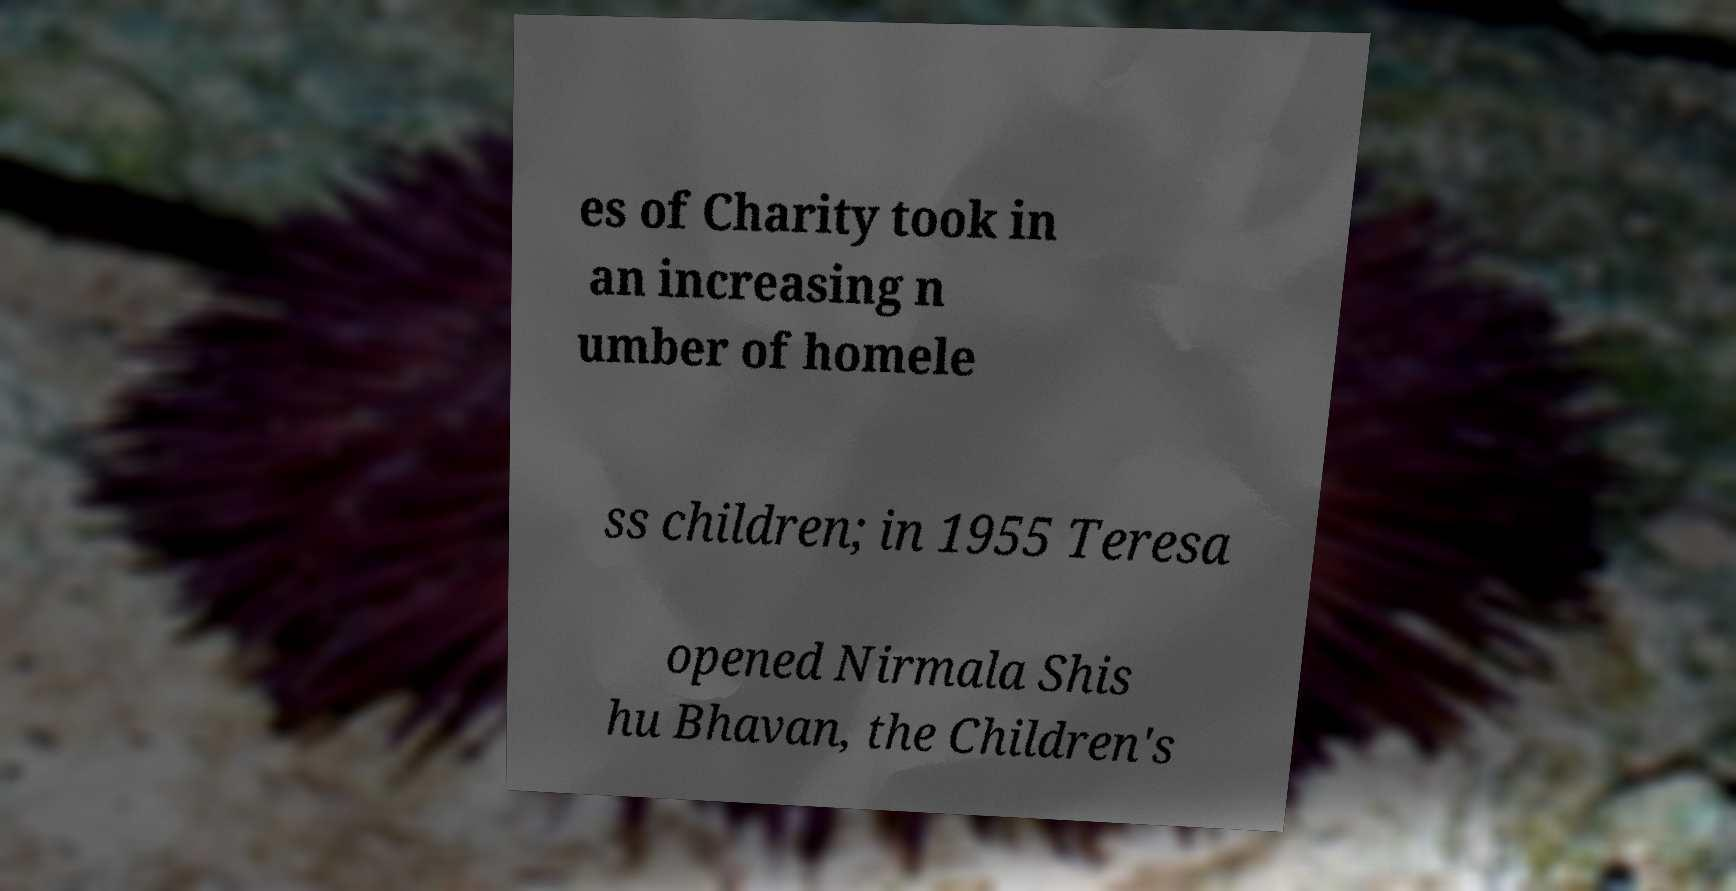What messages or text are displayed in this image? I need them in a readable, typed format. es of Charity took in an increasing n umber of homele ss children; in 1955 Teresa opened Nirmala Shis hu Bhavan, the Children's 